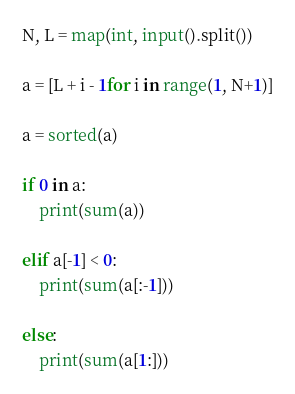Convert code to text. <code><loc_0><loc_0><loc_500><loc_500><_Python_>N, L = map(int, input().split()) 

a = [L + i - 1for i in range(1, N+1)]

a = sorted(a)

if 0 in a:
    print(sum(a))
    
elif a[-1] < 0:
    print(sum(a[:-1]))
    
else:
    print(sum(a[1:]))</code> 